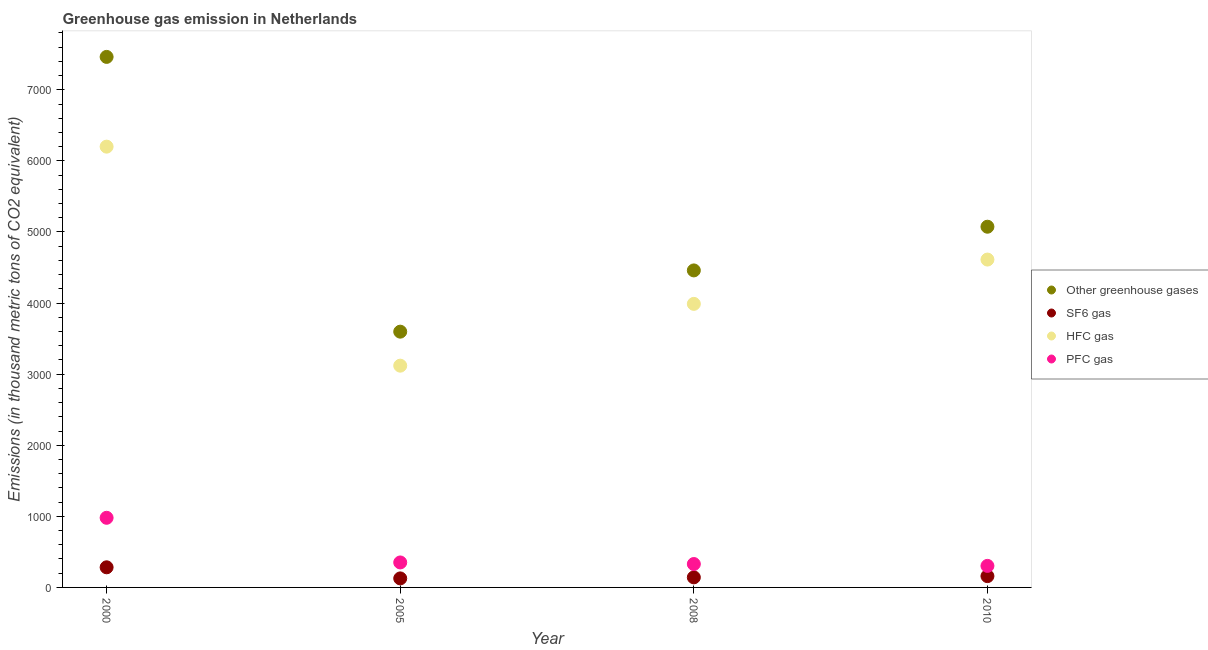What is the emission of pfc gas in 2010?
Ensure brevity in your answer.  303. Across all years, what is the maximum emission of greenhouse gases?
Offer a terse response. 7462.9. Across all years, what is the minimum emission of greenhouse gases?
Provide a short and direct response. 3597.8. In which year was the emission of sf6 gas maximum?
Your answer should be compact. 2000. What is the total emission of greenhouse gases in the graph?
Your answer should be very brief. 2.06e+04. What is the difference between the emission of greenhouse gases in 2000 and that in 2005?
Make the answer very short. 3865.1. What is the difference between the emission of greenhouse gases in 2010 and the emission of pfc gas in 2000?
Offer a very short reply. 4094.5. What is the average emission of pfc gas per year?
Keep it short and to the point. 490.78. In the year 2008, what is the difference between the emission of pfc gas and emission of hfc gas?
Give a very brief answer. -3659.6. What is the ratio of the emission of pfc gas in 2005 to that in 2010?
Ensure brevity in your answer.  1.16. Is the emission of hfc gas in 2000 less than that in 2005?
Give a very brief answer. No. What is the difference between the highest and the second highest emission of greenhouse gases?
Provide a short and direct response. 2388.9. What is the difference between the highest and the lowest emission of pfc gas?
Provide a short and direct response. 676.5. Is the sum of the emission of pfc gas in 2005 and 2010 greater than the maximum emission of sf6 gas across all years?
Ensure brevity in your answer.  Yes. Is it the case that in every year, the sum of the emission of hfc gas and emission of greenhouse gases is greater than the sum of emission of pfc gas and emission of sf6 gas?
Offer a very short reply. Yes. Does the emission of sf6 gas monotonically increase over the years?
Ensure brevity in your answer.  No. How many dotlines are there?
Provide a succinct answer. 4. How many years are there in the graph?
Ensure brevity in your answer.  4. What is the difference between two consecutive major ticks on the Y-axis?
Provide a short and direct response. 1000. Are the values on the major ticks of Y-axis written in scientific E-notation?
Provide a short and direct response. No. Does the graph contain any zero values?
Your response must be concise. No. Where does the legend appear in the graph?
Give a very brief answer. Center right. How many legend labels are there?
Give a very brief answer. 4. What is the title of the graph?
Your response must be concise. Greenhouse gas emission in Netherlands. What is the label or title of the X-axis?
Offer a terse response. Year. What is the label or title of the Y-axis?
Ensure brevity in your answer.  Emissions (in thousand metric tons of CO2 equivalent). What is the Emissions (in thousand metric tons of CO2 equivalent) in Other greenhouse gases in 2000?
Ensure brevity in your answer.  7462.9. What is the Emissions (in thousand metric tons of CO2 equivalent) of SF6 gas in 2000?
Offer a very short reply. 283. What is the Emissions (in thousand metric tons of CO2 equivalent) in HFC gas in 2000?
Provide a succinct answer. 6200.4. What is the Emissions (in thousand metric tons of CO2 equivalent) of PFC gas in 2000?
Your response must be concise. 979.5. What is the Emissions (in thousand metric tons of CO2 equivalent) of Other greenhouse gases in 2005?
Provide a short and direct response. 3597.8. What is the Emissions (in thousand metric tons of CO2 equivalent) in SF6 gas in 2005?
Your answer should be very brief. 126.9. What is the Emissions (in thousand metric tons of CO2 equivalent) of HFC gas in 2005?
Your answer should be very brief. 3119.5. What is the Emissions (in thousand metric tons of CO2 equivalent) in PFC gas in 2005?
Your response must be concise. 351.4. What is the Emissions (in thousand metric tons of CO2 equivalent) in Other greenhouse gases in 2008?
Offer a terse response. 4459.4. What is the Emissions (in thousand metric tons of CO2 equivalent) in SF6 gas in 2008?
Ensure brevity in your answer.  141.4. What is the Emissions (in thousand metric tons of CO2 equivalent) of HFC gas in 2008?
Make the answer very short. 3988.8. What is the Emissions (in thousand metric tons of CO2 equivalent) of PFC gas in 2008?
Keep it short and to the point. 329.2. What is the Emissions (in thousand metric tons of CO2 equivalent) of Other greenhouse gases in 2010?
Provide a short and direct response. 5074. What is the Emissions (in thousand metric tons of CO2 equivalent) of SF6 gas in 2010?
Provide a short and direct response. 159. What is the Emissions (in thousand metric tons of CO2 equivalent) in HFC gas in 2010?
Provide a succinct answer. 4612. What is the Emissions (in thousand metric tons of CO2 equivalent) of PFC gas in 2010?
Keep it short and to the point. 303. Across all years, what is the maximum Emissions (in thousand metric tons of CO2 equivalent) of Other greenhouse gases?
Your response must be concise. 7462.9. Across all years, what is the maximum Emissions (in thousand metric tons of CO2 equivalent) in SF6 gas?
Offer a terse response. 283. Across all years, what is the maximum Emissions (in thousand metric tons of CO2 equivalent) of HFC gas?
Your response must be concise. 6200.4. Across all years, what is the maximum Emissions (in thousand metric tons of CO2 equivalent) in PFC gas?
Offer a very short reply. 979.5. Across all years, what is the minimum Emissions (in thousand metric tons of CO2 equivalent) in Other greenhouse gases?
Your answer should be very brief. 3597.8. Across all years, what is the minimum Emissions (in thousand metric tons of CO2 equivalent) of SF6 gas?
Your answer should be compact. 126.9. Across all years, what is the minimum Emissions (in thousand metric tons of CO2 equivalent) in HFC gas?
Offer a terse response. 3119.5. Across all years, what is the minimum Emissions (in thousand metric tons of CO2 equivalent) in PFC gas?
Provide a succinct answer. 303. What is the total Emissions (in thousand metric tons of CO2 equivalent) in Other greenhouse gases in the graph?
Offer a terse response. 2.06e+04. What is the total Emissions (in thousand metric tons of CO2 equivalent) in SF6 gas in the graph?
Give a very brief answer. 710.3. What is the total Emissions (in thousand metric tons of CO2 equivalent) in HFC gas in the graph?
Offer a very short reply. 1.79e+04. What is the total Emissions (in thousand metric tons of CO2 equivalent) in PFC gas in the graph?
Provide a succinct answer. 1963.1. What is the difference between the Emissions (in thousand metric tons of CO2 equivalent) of Other greenhouse gases in 2000 and that in 2005?
Provide a succinct answer. 3865.1. What is the difference between the Emissions (in thousand metric tons of CO2 equivalent) in SF6 gas in 2000 and that in 2005?
Offer a very short reply. 156.1. What is the difference between the Emissions (in thousand metric tons of CO2 equivalent) of HFC gas in 2000 and that in 2005?
Ensure brevity in your answer.  3080.9. What is the difference between the Emissions (in thousand metric tons of CO2 equivalent) of PFC gas in 2000 and that in 2005?
Offer a terse response. 628.1. What is the difference between the Emissions (in thousand metric tons of CO2 equivalent) of Other greenhouse gases in 2000 and that in 2008?
Keep it short and to the point. 3003.5. What is the difference between the Emissions (in thousand metric tons of CO2 equivalent) of SF6 gas in 2000 and that in 2008?
Your response must be concise. 141.6. What is the difference between the Emissions (in thousand metric tons of CO2 equivalent) in HFC gas in 2000 and that in 2008?
Keep it short and to the point. 2211.6. What is the difference between the Emissions (in thousand metric tons of CO2 equivalent) in PFC gas in 2000 and that in 2008?
Keep it short and to the point. 650.3. What is the difference between the Emissions (in thousand metric tons of CO2 equivalent) of Other greenhouse gases in 2000 and that in 2010?
Provide a succinct answer. 2388.9. What is the difference between the Emissions (in thousand metric tons of CO2 equivalent) of SF6 gas in 2000 and that in 2010?
Your response must be concise. 124. What is the difference between the Emissions (in thousand metric tons of CO2 equivalent) in HFC gas in 2000 and that in 2010?
Provide a short and direct response. 1588.4. What is the difference between the Emissions (in thousand metric tons of CO2 equivalent) in PFC gas in 2000 and that in 2010?
Ensure brevity in your answer.  676.5. What is the difference between the Emissions (in thousand metric tons of CO2 equivalent) of Other greenhouse gases in 2005 and that in 2008?
Offer a terse response. -861.6. What is the difference between the Emissions (in thousand metric tons of CO2 equivalent) in HFC gas in 2005 and that in 2008?
Offer a very short reply. -869.3. What is the difference between the Emissions (in thousand metric tons of CO2 equivalent) of Other greenhouse gases in 2005 and that in 2010?
Make the answer very short. -1476.2. What is the difference between the Emissions (in thousand metric tons of CO2 equivalent) in SF6 gas in 2005 and that in 2010?
Your answer should be very brief. -32.1. What is the difference between the Emissions (in thousand metric tons of CO2 equivalent) of HFC gas in 2005 and that in 2010?
Ensure brevity in your answer.  -1492.5. What is the difference between the Emissions (in thousand metric tons of CO2 equivalent) of PFC gas in 2005 and that in 2010?
Offer a terse response. 48.4. What is the difference between the Emissions (in thousand metric tons of CO2 equivalent) in Other greenhouse gases in 2008 and that in 2010?
Provide a short and direct response. -614.6. What is the difference between the Emissions (in thousand metric tons of CO2 equivalent) of SF6 gas in 2008 and that in 2010?
Keep it short and to the point. -17.6. What is the difference between the Emissions (in thousand metric tons of CO2 equivalent) of HFC gas in 2008 and that in 2010?
Provide a short and direct response. -623.2. What is the difference between the Emissions (in thousand metric tons of CO2 equivalent) in PFC gas in 2008 and that in 2010?
Your response must be concise. 26.2. What is the difference between the Emissions (in thousand metric tons of CO2 equivalent) in Other greenhouse gases in 2000 and the Emissions (in thousand metric tons of CO2 equivalent) in SF6 gas in 2005?
Your answer should be compact. 7336. What is the difference between the Emissions (in thousand metric tons of CO2 equivalent) of Other greenhouse gases in 2000 and the Emissions (in thousand metric tons of CO2 equivalent) of HFC gas in 2005?
Ensure brevity in your answer.  4343.4. What is the difference between the Emissions (in thousand metric tons of CO2 equivalent) of Other greenhouse gases in 2000 and the Emissions (in thousand metric tons of CO2 equivalent) of PFC gas in 2005?
Your answer should be very brief. 7111.5. What is the difference between the Emissions (in thousand metric tons of CO2 equivalent) in SF6 gas in 2000 and the Emissions (in thousand metric tons of CO2 equivalent) in HFC gas in 2005?
Your answer should be compact. -2836.5. What is the difference between the Emissions (in thousand metric tons of CO2 equivalent) of SF6 gas in 2000 and the Emissions (in thousand metric tons of CO2 equivalent) of PFC gas in 2005?
Provide a succinct answer. -68.4. What is the difference between the Emissions (in thousand metric tons of CO2 equivalent) in HFC gas in 2000 and the Emissions (in thousand metric tons of CO2 equivalent) in PFC gas in 2005?
Provide a short and direct response. 5849. What is the difference between the Emissions (in thousand metric tons of CO2 equivalent) of Other greenhouse gases in 2000 and the Emissions (in thousand metric tons of CO2 equivalent) of SF6 gas in 2008?
Provide a succinct answer. 7321.5. What is the difference between the Emissions (in thousand metric tons of CO2 equivalent) in Other greenhouse gases in 2000 and the Emissions (in thousand metric tons of CO2 equivalent) in HFC gas in 2008?
Your answer should be very brief. 3474.1. What is the difference between the Emissions (in thousand metric tons of CO2 equivalent) of Other greenhouse gases in 2000 and the Emissions (in thousand metric tons of CO2 equivalent) of PFC gas in 2008?
Offer a very short reply. 7133.7. What is the difference between the Emissions (in thousand metric tons of CO2 equivalent) of SF6 gas in 2000 and the Emissions (in thousand metric tons of CO2 equivalent) of HFC gas in 2008?
Provide a short and direct response. -3705.8. What is the difference between the Emissions (in thousand metric tons of CO2 equivalent) of SF6 gas in 2000 and the Emissions (in thousand metric tons of CO2 equivalent) of PFC gas in 2008?
Ensure brevity in your answer.  -46.2. What is the difference between the Emissions (in thousand metric tons of CO2 equivalent) of HFC gas in 2000 and the Emissions (in thousand metric tons of CO2 equivalent) of PFC gas in 2008?
Your answer should be compact. 5871.2. What is the difference between the Emissions (in thousand metric tons of CO2 equivalent) of Other greenhouse gases in 2000 and the Emissions (in thousand metric tons of CO2 equivalent) of SF6 gas in 2010?
Offer a terse response. 7303.9. What is the difference between the Emissions (in thousand metric tons of CO2 equivalent) of Other greenhouse gases in 2000 and the Emissions (in thousand metric tons of CO2 equivalent) of HFC gas in 2010?
Keep it short and to the point. 2850.9. What is the difference between the Emissions (in thousand metric tons of CO2 equivalent) in Other greenhouse gases in 2000 and the Emissions (in thousand metric tons of CO2 equivalent) in PFC gas in 2010?
Your answer should be very brief. 7159.9. What is the difference between the Emissions (in thousand metric tons of CO2 equivalent) in SF6 gas in 2000 and the Emissions (in thousand metric tons of CO2 equivalent) in HFC gas in 2010?
Offer a terse response. -4329. What is the difference between the Emissions (in thousand metric tons of CO2 equivalent) of HFC gas in 2000 and the Emissions (in thousand metric tons of CO2 equivalent) of PFC gas in 2010?
Provide a succinct answer. 5897.4. What is the difference between the Emissions (in thousand metric tons of CO2 equivalent) in Other greenhouse gases in 2005 and the Emissions (in thousand metric tons of CO2 equivalent) in SF6 gas in 2008?
Your answer should be compact. 3456.4. What is the difference between the Emissions (in thousand metric tons of CO2 equivalent) in Other greenhouse gases in 2005 and the Emissions (in thousand metric tons of CO2 equivalent) in HFC gas in 2008?
Keep it short and to the point. -391. What is the difference between the Emissions (in thousand metric tons of CO2 equivalent) in Other greenhouse gases in 2005 and the Emissions (in thousand metric tons of CO2 equivalent) in PFC gas in 2008?
Your answer should be compact. 3268.6. What is the difference between the Emissions (in thousand metric tons of CO2 equivalent) of SF6 gas in 2005 and the Emissions (in thousand metric tons of CO2 equivalent) of HFC gas in 2008?
Ensure brevity in your answer.  -3861.9. What is the difference between the Emissions (in thousand metric tons of CO2 equivalent) in SF6 gas in 2005 and the Emissions (in thousand metric tons of CO2 equivalent) in PFC gas in 2008?
Offer a terse response. -202.3. What is the difference between the Emissions (in thousand metric tons of CO2 equivalent) in HFC gas in 2005 and the Emissions (in thousand metric tons of CO2 equivalent) in PFC gas in 2008?
Ensure brevity in your answer.  2790.3. What is the difference between the Emissions (in thousand metric tons of CO2 equivalent) in Other greenhouse gases in 2005 and the Emissions (in thousand metric tons of CO2 equivalent) in SF6 gas in 2010?
Make the answer very short. 3438.8. What is the difference between the Emissions (in thousand metric tons of CO2 equivalent) in Other greenhouse gases in 2005 and the Emissions (in thousand metric tons of CO2 equivalent) in HFC gas in 2010?
Offer a terse response. -1014.2. What is the difference between the Emissions (in thousand metric tons of CO2 equivalent) of Other greenhouse gases in 2005 and the Emissions (in thousand metric tons of CO2 equivalent) of PFC gas in 2010?
Your response must be concise. 3294.8. What is the difference between the Emissions (in thousand metric tons of CO2 equivalent) of SF6 gas in 2005 and the Emissions (in thousand metric tons of CO2 equivalent) of HFC gas in 2010?
Your answer should be very brief. -4485.1. What is the difference between the Emissions (in thousand metric tons of CO2 equivalent) of SF6 gas in 2005 and the Emissions (in thousand metric tons of CO2 equivalent) of PFC gas in 2010?
Provide a short and direct response. -176.1. What is the difference between the Emissions (in thousand metric tons of CO2 equivalent) of HFC gas in 2005 and the Emissions (in thousand metric tons of CO2 equivalent) of PFC gas in 2010?
Your response must be concise. 2816.5. What is the difference between the Emissions (in thousand metric tons of CO2 equivalent) of Other greenhouse gases in 2008 and the Emissions (in thousand metric tons of CO2 equivalent) of SF6 gas in 2010?
Offer a terse response. 4300.4. What is the difference between the Emissions (in thousand metric tons of CO2 equivalent) of Other greenhouse gases in 2008 and the Emissions (in thousand metric tons of CO2 equivalent) of HFC gas in 2010?
Make the answer very short. -152.6. What is the difference between the Emissions (in thousand metric tons of CO2 equivalent) of Other greenhouse gases in 2008 and the Emissions (in thousand metric tons of CO2 equivalent) of PFC gas in 2010?
Offer a terse response. 4156.4. What is the difference between the Emissions (in thousand metric tons of CO2 equivalent) in SF6 gas in 2008 and the Emissions (in thousand metric tons of CO2 equivalent) in HFC gas in 2010?
Keep it short and to the point. -4470.6. What is the difference between the Emissions (in thousand metric tons of CO2 equivalent) of SF6 gas in 2008 and the Emissions (in thousand metric tons of CO2 equivalent) of PFC gas in 2010?
Make the answer very short. -161.6. What is the difference between the Emissions (in thousand metric tons of CO2 equivalent) in HFC gas in 2008 and the Emissions (in thousand metric tons of CO2 equivalent) in PFC gas in 2010?
Keep it short and to the point. 3685.8. What is the average Emissions (in thousand metric tons of CO2 equivalent) in Other greenhouse gases per year?
Ensure brevity in your answer.  5148.52. What is the average Emissions (in thousand metric tons of CO2 equivalent) of SF6 gas per year?
Ensure brevity in your answer.  177.57. What is the average Emissions (in thousand metric tons of CO2 equivalent) in HFC gas per year?
Your response must be concise. 4480.18. What is the average Emissions (in thousand metric tons of CO2 equivalent) of PFC gas per year?
Your response must be concise. 490.77. In the year 2000, what is the difference between the Emissions (in thousand metric tons of CO2 equivalent) of Other greenhouse gases and Emissions (in thousand metric tons of CO2 equivalent) of SF6 gas?
Make the answer very short. 7179.9. In the year 2000, what is the difference between the Emissions (in thousand metric tons of CO2 equivalent) in Other greenhouse gases and Emissions (in thousand metric tons of CO2 equivalent) in HFC gas?
Ensure brevity in your answer.  1262.5. In the year 2000, what is the difference between the Emissions (in thousand metric tons of CO2 equivalent) of Other greenhouse gases and Emissions (in thousand metric tons of CO2 equivalent) of PFC gas?
Your response must be concise. 6483.4. In the year 2000, what is the difference between the Emissions (in thousand metric tons of CO2 equivalent) of SF6 gas and Emissions (in thousand metric tons of CO2 equivalent) of HFC gas?
Provide a short and direct response. -5917.4. In the year 2000, what is the difference between the Emissions (in thousand metric tons of CO2 equivalent) in SF6 gas and Emissions (in thousand metric tons of CO2 equivalent) in PFC gas?
Offer a very short reply. -696.5. In the year 2000, what is the difference between the Emissions (in thousand metric tons of CO2 equivalent) of HFC gas and Emissions (in thousand metric tons of CO2 equivalent) of PFC gas?
Make the answer very short. 5220.9. In the year 2005, what is the difference between the Emissions (in thousand metric tons of CO2 equivalent) of Other greenhouse gases and Emissions (in thousand metric tons of CO2 equivalent) of SF6 gas?
Ensure brevity in your answer.  3470.9. In the year 2005, what is the difference between the Emissions (in thousand metric tons of CO2 equivalent) in Other greenhouse gases and Emissions (in thousand metric tons of CO2 equivalent) in HFC gas?
Provide a succinct answer. 478.3. In the year 2005, what is the difference between the Emissions (in thousand metric tons of CO2 equivalent) in Other greenhouse gases and Emissions (in thousand metric tons of CO2 equivalent) in PFC gas?
Your response must be concise. 3246.4. In the year 2005, what is the difference between the Emissions (in thousand metric tons of CO2 equivalent) of SF6 gas and Emissions (in thousand metric tons of CO2 equivalent) of HFC gas?
Offer a terse response. -2992.6. In the year 2005, what is the difference between the Emissions (in thousand metric tons of CO2 equivalent) of SF6 gas and Emissions (in thousand metric tons of CO2 equivalent) of PFC gas?
Ensure brevity in your answer.  -224.5. In the year 2005, what is the difference between the Emissions (in thousand metric tons of CO2 equivalent) of HFC gas and Emissions (in thousand metric tons of CO2 equivalent) of PFC gas?
Your answer should be very brief. 2768.1. In the year 2008, what is the difference between the Emissions (in thousand metric tons of CO2 equivalent) in Other greenhouse gases and Emissions (in thousand metric tons of CO2 equivalent) in SF6 gas?
Keep it short and to the point. 4318. In the year 2008, what is the difference between the Emissions (in thousand metric tons of CO2 equivalent) in Other greenhouse gases and Emissions (in thousand metric tons of CO2 equivalent) in HFC gas?
Your response must be concise. 470.6. In the year 2008, what is the difference between the Emissions (in thousand metric tons of CO2 equivalent) of Other greenhouse gases and Emissions (in thousand metric tons of CO2 equivalent) of PFC gas?
Your answer should be very brief. 4130.2. In the year 2008, what is the difference between the Emissions (in thousand metric tons of CO2 equivalent) in SF6 gas and Emissions (in thousand metric tons of CO2 equivalent) in HFC gas?
Provide a short and direct response. -3847.4. In the year 2008, what is the difference between the Emissions (in thousand metric tons of CO2 equivalent) in SF6 gas and Emissions (in thousand metric tons of CO2 equivalent) in PFC gas?
Offer a terse response. -187.8. In the year 2008, what is the difference between the Emissions (in thousand metric tons of CO2 equivalent) in HFC gas and Emissions (in thousand metric tons of CO2 equivalent) in PFC gas?
Give a very brief answer. 3659.6. In the year 2010, what is the difference between the Emissions (in thousand metric tons of CO2 equivalent) in Other greenhouse gases and Emissions (in thousand metric tons of CO2 equivalent) in SF6 gas?
Provide a short and direct response. 4915. In the year 2010, what is the difference between the Emissions (in thousand metric tons of CO2 equivalent) of Other greenhouse gases and Emissions (in thousand metric tons of CO2 equivalent) of HFC gas?
Give a very brief answer. 462. In the year 2010, what is the difference between the Emissions (in thousand metric tons of CO2 equivalent) in Other greenhouse gases and Emissions (in thousand metric tons of CO2 equivalent) in PFC gas?
Your response must be concise. 4771. In the year 2010, what is the difference between the Emissions (in thousand metric tons of CO2 equivalent) of SF6 gas and Emissions (in thousand metric tons of CO2 equivalent) of HFC gas?
Provide a short and direct response. -4453. In the year 2010, what is the difference between the Emissions (in thousand metric tons of CO2 equivalent) of SF6 gas and Emissions (in thousand metric tons of CO2 equivalent) of PFC gas?
Offer a terse response. -144. In the year 2010, what is the difference between the Emissions (in thousand metric tons of CO2 equivalent) of HFC gas and Emissions (in thousand metric tons of CO2 equivalent) of PFC gas?
Offer a very short reply. 4309. What is the ratio of the Emissions (in thousand metric tons of CO2 equivalent) of Other greenhouse gases in 2000 to that in 2005?
Make the answer very short. 2.07. What is the ratio of the Emissions (in thousand metric tons of CO2 equivalent) in SF6 gas in 2000 to that in 2005?
Your answer should be compact. 2.23. What is the ratio of the Emissions (in thousand metric tons of CO2 equivalent) in HFC gas in 2000 to that in 2005?
Your response must be concise. 1.99. What is the ratio of the Emissions (in thousand metric tons of CO2 equivalent) of PFC gas in 2000 to that in 2005?
Give a very brief answer. 2.79. What is the ratio of the Emissions (in thousand metric tons of CO2 equivalent) in Other greenhouse gases in 2000 to that in 2008?
Ensure brevity in your answer.  1.67. What is the ratio of the Emissions (in thousand metric tons of CO2 equivalent) of SF6 gas in 2000 to that in 2008?
Provide a short and direct response. 2. What is the ratio of the Emissions (in thousand metric tons of CO2 equivalent) of HFC gas in 2000 to that in 2008?
Your answer should be very brief. 1.55. What is the ratio of the Emissions (in thousand metric tons of CO2 equivalent) in PFC gas in 2000 to that in 2008?
Provide a short and direct response. 2.98. What is the ratio of the Emissions (in thousand metric tons of CO2 equivalent) in Other greenhouse gases in 2000 to that in 2010?
Give a very brief answer. 1.47. What is the ratio of the Emissions (in thousand metric tons of CO2 equivalent) in SF6 gas in 2000 to that in 2010?
Your answer should be very brief. 1.78. What is the ratio of the Emissions (in thousand metric tons of CO2 equivalent) in HFC gas in 2000 to that in 2010?
Provide a succinct answer. 1.34. What is the ratio of the Emissions (in thousand metric tons of CO2 equivalent) in PFC gas in 2000 to that in 2010?
Offer a very short reply. 3.23. What is the ratio of the Emissions (in thousand metric tons of CO2 equivalent) of Other greenhouse gases in 2005 to that in 2008?
Ensure brevity in your answer.  0.81. What is the ratio of the Emissions (in thousand metric tons of CO2 equivalent) in SF6 gas in 2005 to that in 2008?
Give a very brief answer. 0.9. What is the ratio of the Emissions (in thousand metric tons of CO2 equivalent) of HFC gas in 2005 to that in 2008?
Give a very brief answer. 0.78. What is the ratio of the Emissions (in thousand metric tons of CO2 equivalent) of PFC gas in 2005 to that in 2008?
Your answer should be very brief. 1.07. What is the ratio of the Emissions (in thousand metric tons of CO2 equivalent) of Other greenhouse gases in 2005 to that in 2010?
Provide a succinct answer. 0.71. What is the ratio of the Emissions (in thousand metric tons of CO2 equivalent) in SF6 gas in 2005 to that in 2010?
Make the answer very short. 0.8. What is the ratio of the Emissions (in thousand metric tons of CO2 equivalent) of HFC gas in 2005 to that in 2010?
Offer a terse response. 0.68. What is the ratio of the Emissions (in thousand metric tons of CO2 equivalent) of PFC gas in 2005 to that in 2010?
Offer a very short reply. 1.16. What is the ratio of the Emissions (in thousand metric tons of CO2 equivalent) in Other greenhouse gases in 2008 to that in 2010?
Provide a succinct answer. 0.88. What is the ratio of the Emissions (in thousand metric tons of CO2 equivalent) in SF6 gas in 2008 to that in 2010?
Give a very brief answer. 0.89. What is the ratio of the Emissions (in thousand metric tons of CO2 equivalent) of HFC gas in 2008 to that in 2010?
Keep it short and to the point. 0.86. What is the ratio of the Emissions (in thousand metric tons of CO2 equivalent) of PFC gas in 2008 to that in 2010?
Give a very brief answer. 1.09. What is the difference between the highest and the second highest Emissions (in thousand metric tons of CO2 equivalent) in Other greenhouse gases?
Your answer should be very brief. 2388.9. What is the difference between the highest and the second highest Emissions (in thousand metric tons of CO2 equivalent) in SF6 gas?
Your answer should be compact. 124. What is the difference between the highest and the second highest Emissions (in thousand metric tons of CO2 equivalent) in HFC gas?
Your response must be concise. 1588.4. What is the difference between the highest and the second highest Emissions (in thousand metric tons of CO2 equivalent) of PFC gas?
Give a very brief answer. 628.1. What is the difference between the highest and the lowest Emissions (in thousand metric tons of CO2 equivalent) in Other greenhouse gases?
Offer a terse response. 3865.1. What is the difference between the highest and the lowest Emissions (in thousand metric tons of CO2 equivalent) of SF6 gas?
Provide a short and direct response. 156.1. What is the difference between the highest and the lowest Emissions (in thousand metric tons of CO2 equivalent) in HFC gas?
Offer a very short reply. 3080.9. What is the difference between the highest and the lowest Emissions (in thousand metric tons of CO2 equivalent) in PFC gas?
Your answer should be compact. 676.5. 